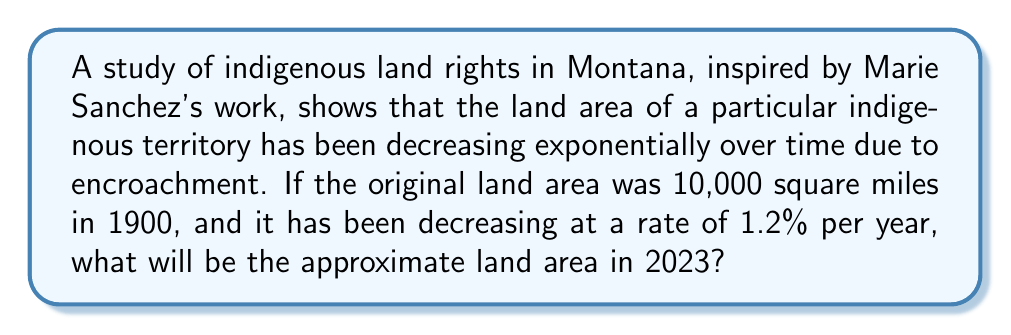Solve this math problem. To solve this problem, we'll use the exponential decay formula:

$$A(t) = A_0 \cdot (1-r)^t$$

Where:
$A(t)$ is the area at time $t$
$A_0$ is the initial area
$r$ is the rate of decrease per year
$t$ is the number of years

Given:
$A_0 = 10,000$ square miles
$r = 0.012$ (1.2% expressed as a decimal)
$t = 2023 - 1900 = 123$ years

Let's plug these values into the formula:

$$A(123) = 10,000 \cdot (1-0.012)^{123}$$

Using a calculator or computer:

$$(1-0.012)^{123} \approx 0.2284$$

Therefore:

$$A(123) = 10,000 \cdot 0.2284 \approx 2,284$$

The land area in 2023 will be approximately 2,284 square miles.
Answer: 2,284 square miles 